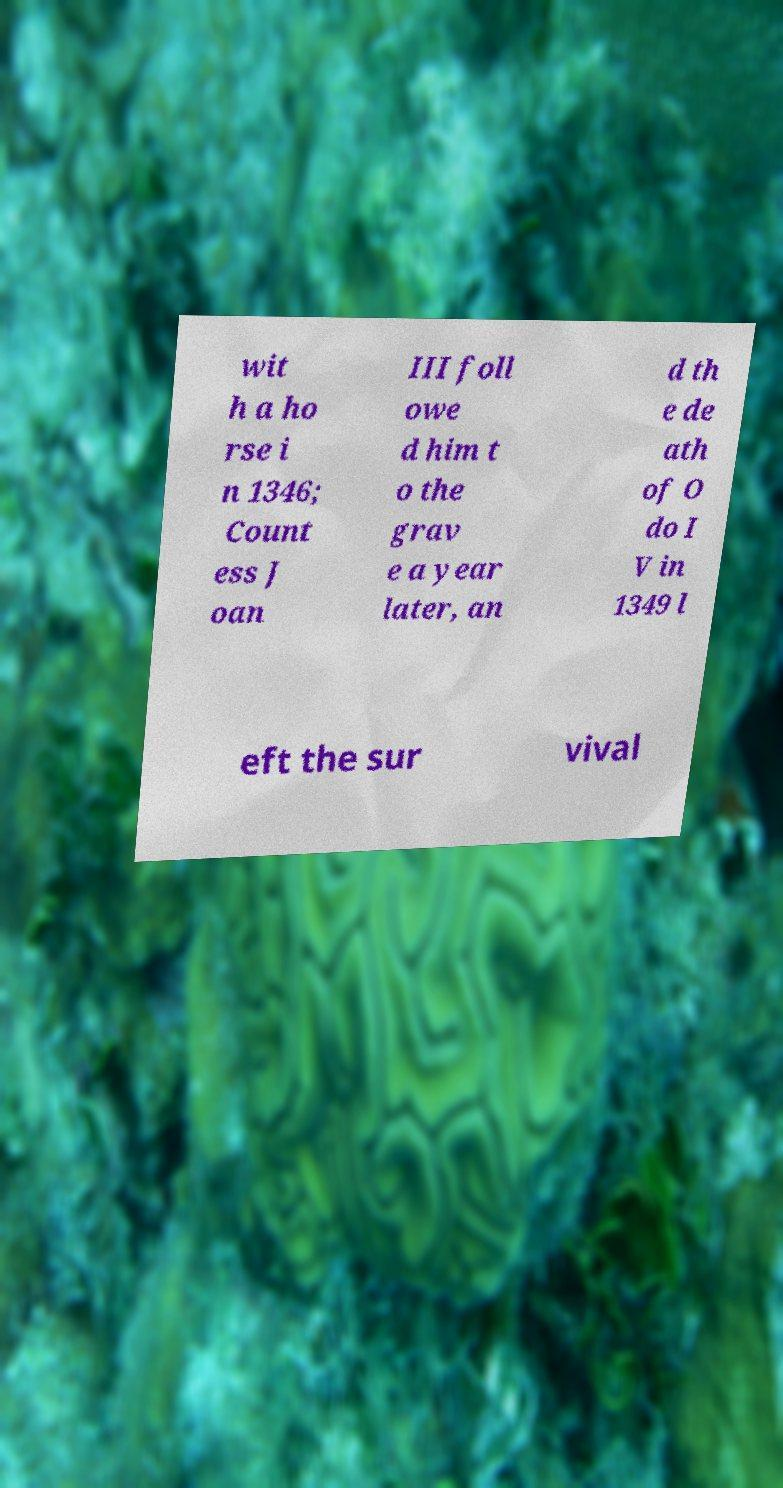Can you accurately transcribe the text from the provided image for me? wit h a ho rse i n 1346; Count ess J oan III foll owe d him t o the grav e a year later, an d th e de ath of O do I V in 1349 l eft the sur vival 